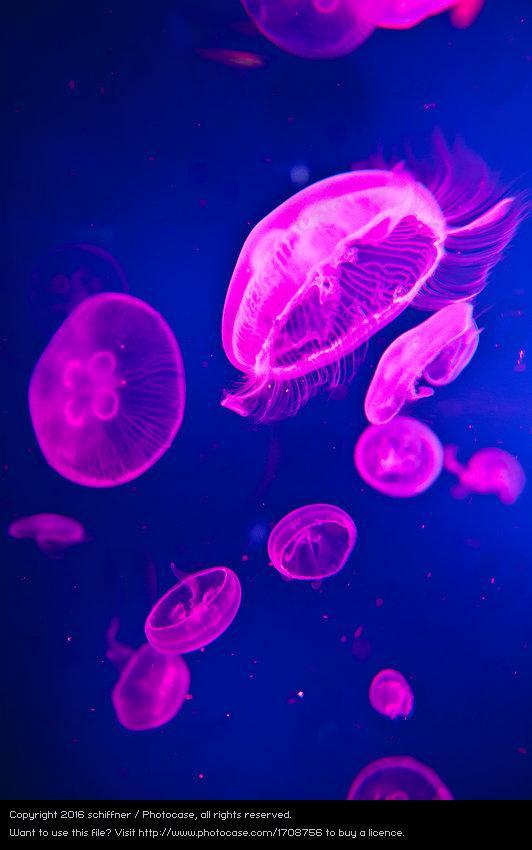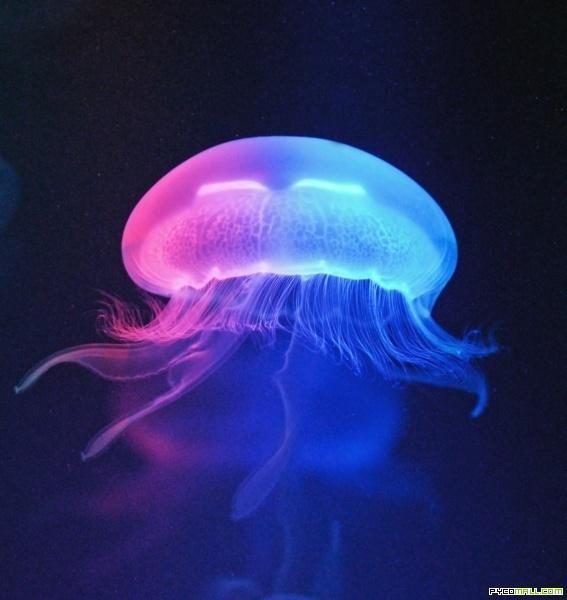The first image is the image on the left, the second image is the image on the right. Analyze the images presented: Is the assertion "One of the images features exactly one jelly fish." valid? Answer yes or no. Yes. 